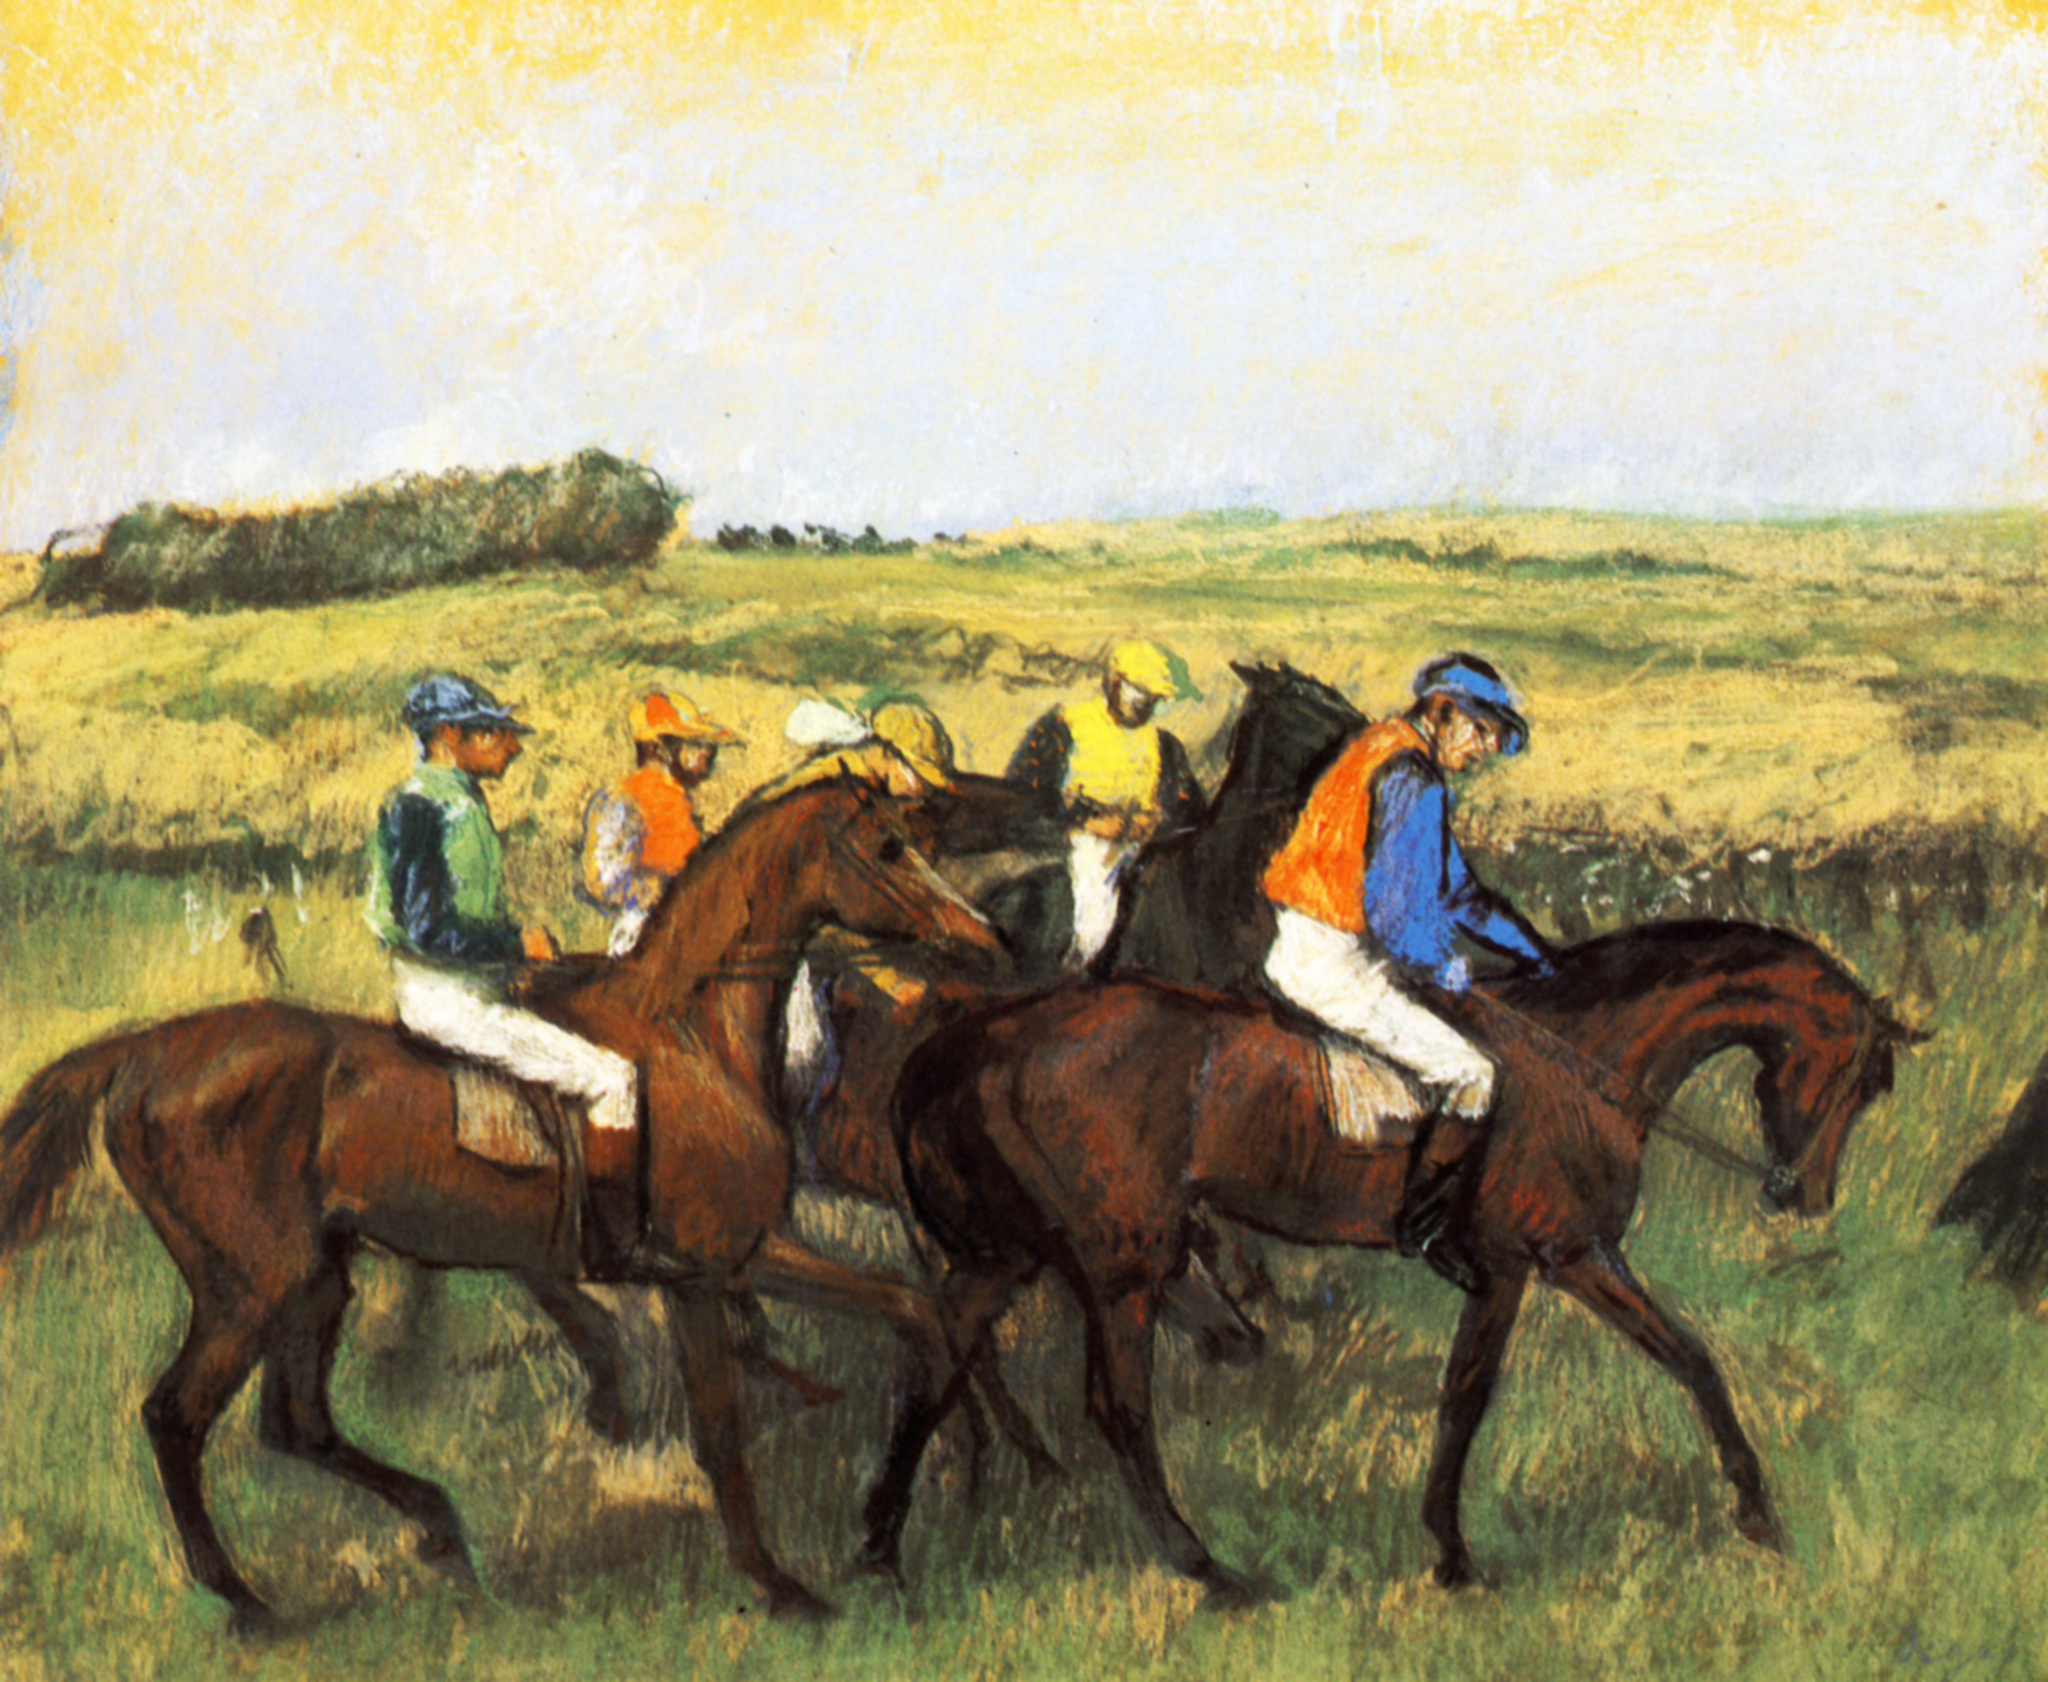What are the key elements in this picture?
 The image is a vibrant impressionist painting capturing a dynamic horse race. The scene is filled with jockeys on horseback, their bodies leaning forward in the heat of the competition. They are adorned in colorful silks and helmets, adding a splash of color against the natural tones of the horses. The horses, caught in mid-gallop, embody the energy and excitement of the race. The background is a simple, yet effective, depiction of a grassy field under a blue sky dotted with a few clouds. The loose, sketchy style of the painting, a characteristic of the impressionist genre, enhances the sense of movement and energy in the scene. The bright colors used throughout the painting further contribute to the overall mood of excitement. 